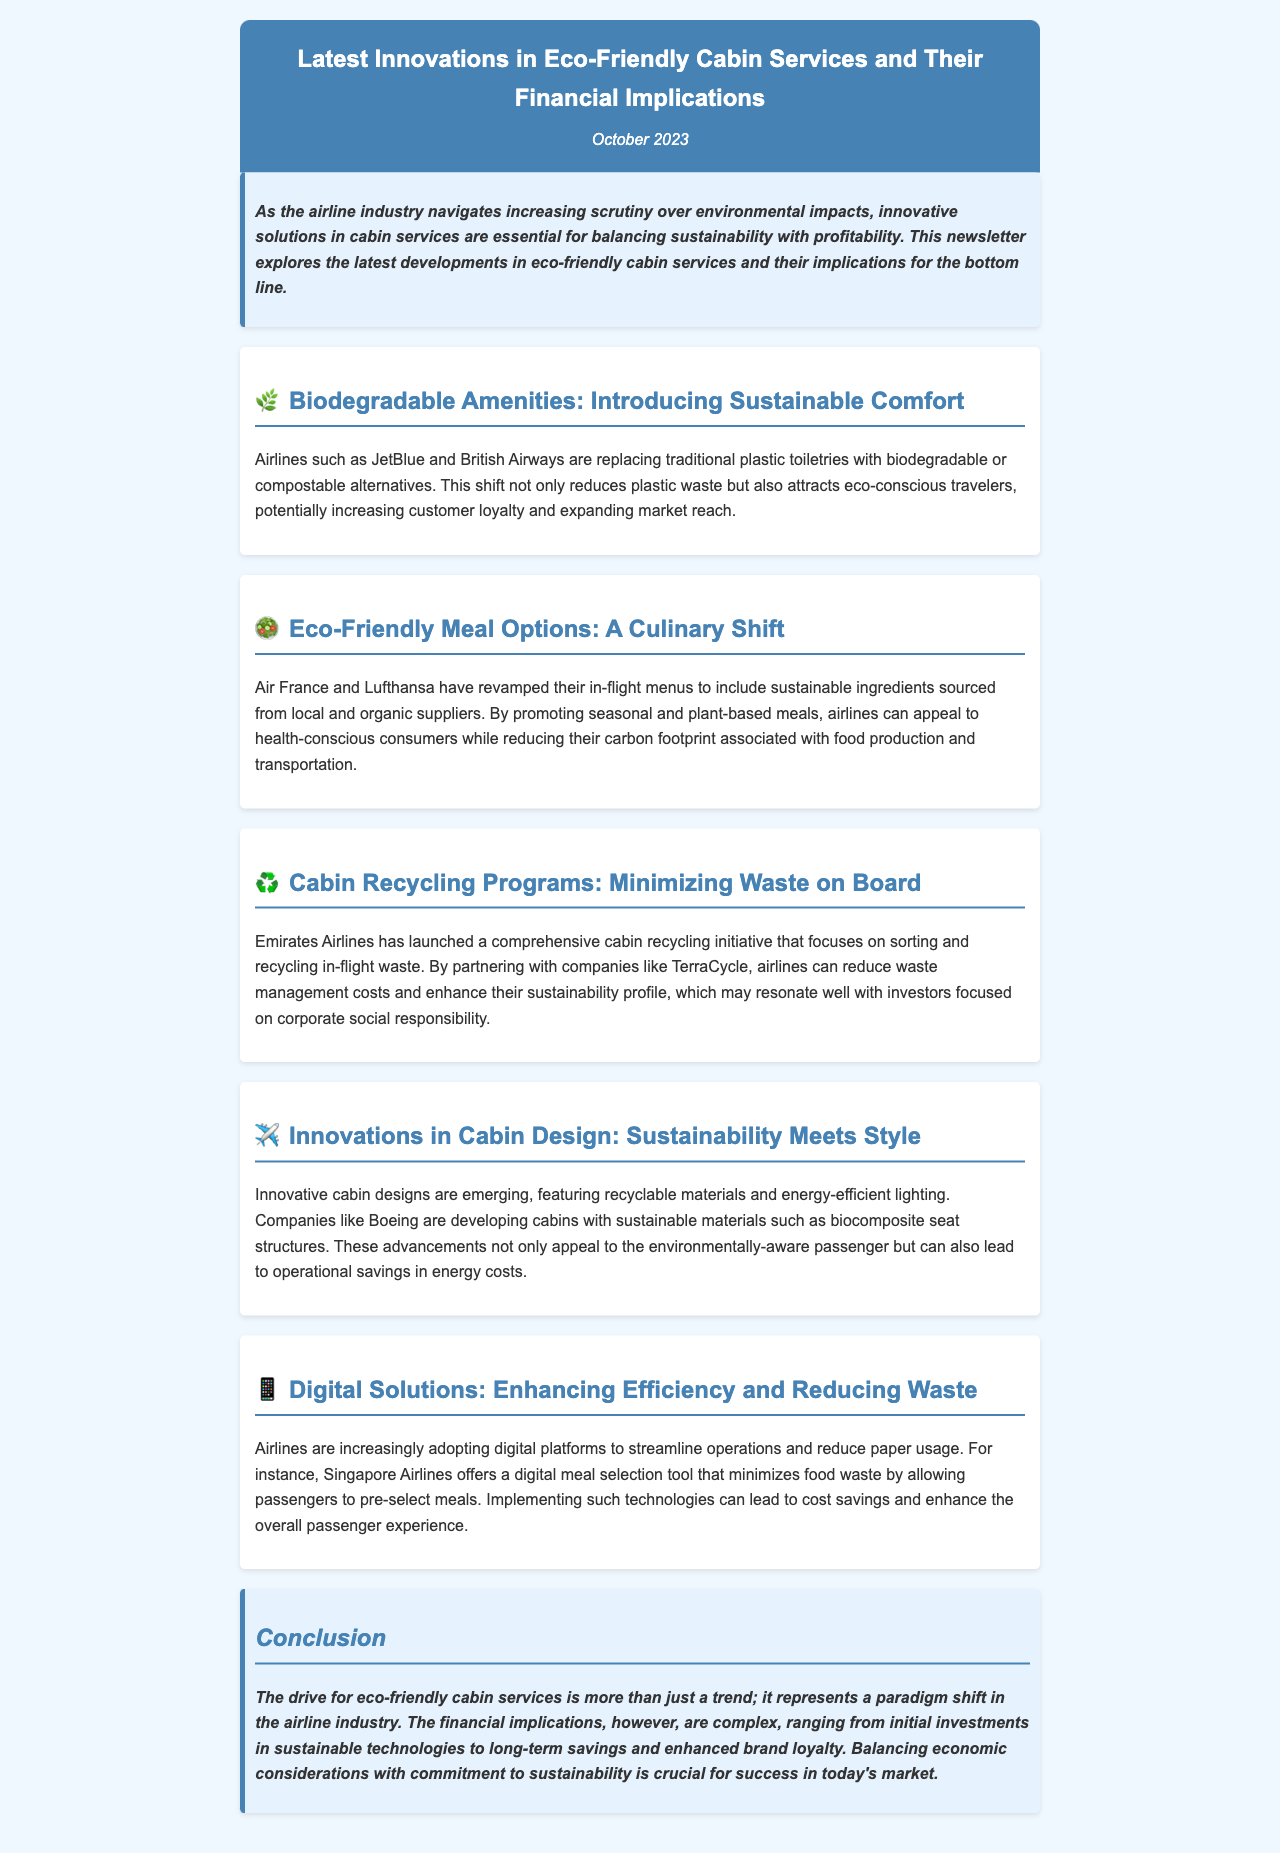What airlines are introducing biodegradable amenities? The airlines mentioned are JetBlue and British Airways, which are replacing plastic toiletries with biodegradable alternatives.
Answer: JetBlue and British Airways What culinary shift is being adopted by Air France and Lufthansa? They have revamped their in-flight menus to include sustainable ingredients sourced from local and organic suppliers.
Answer: Sustainable ingredients What initiative has Emirates Airlines launched? Emirates Airlines has launched a comprehensive cabin recycling initiative focusing on sorting and recycling in-flight waste.
Answer: Cabin recycling initiative Who is developing cabins with sustainable materials? Boeing is developing cabins with sustainable materials such as biocomposite seat structures.
Answer: Boeing What digital tool does Singapore Airlines offer to minimize food waste? Singapore Airlines offers a digital meal selection tool that allows passengers to pre-select meals.
Answer: Digital meal selection tool What is the main purpose of the newsletter? The newsletter aims to explore the latest developments in eco-friendly cabin services and their implications for the bottom line.
Answer: Explore innovations in eco-friendly cabin services What type of materials are being featured in innovative cabin designs? The materials being featured are recyclable materials and energy-efficient lighting.
Answer: Recyclable materials What are the financial implications of eco-friendly services described as? The financial implications are described as complex, involving initial investments and long-term savings.
Answer: Complex 